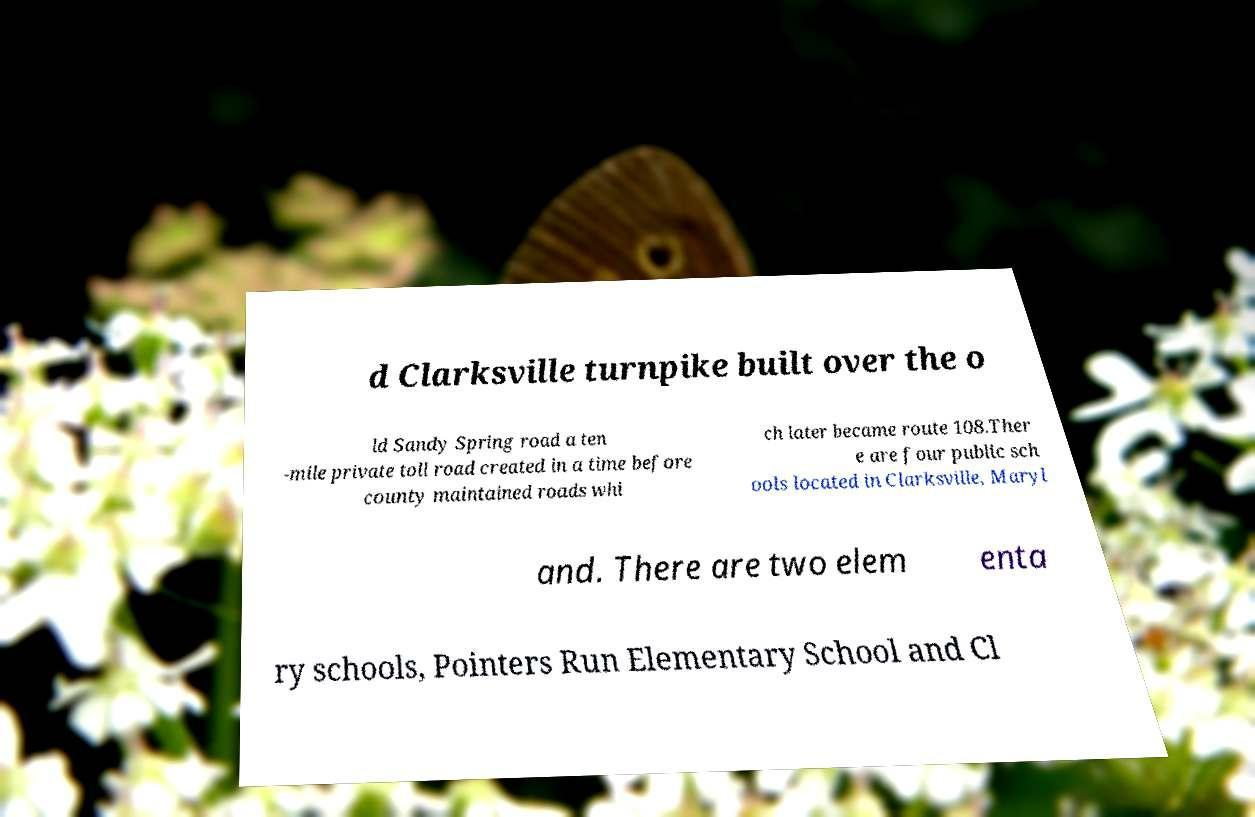Please read and relay the text visible in this image. What does it say? d Clarksville turnpike built over the o ld Sandy Spring road a ten -mile private toll road created in a time before county maintained roads whi ch later became route 108.Ther e are four public sch ools located in Clarksville, Maryl and. There are two elem enta ry schools, Pointers Run Elementary School and Cl 